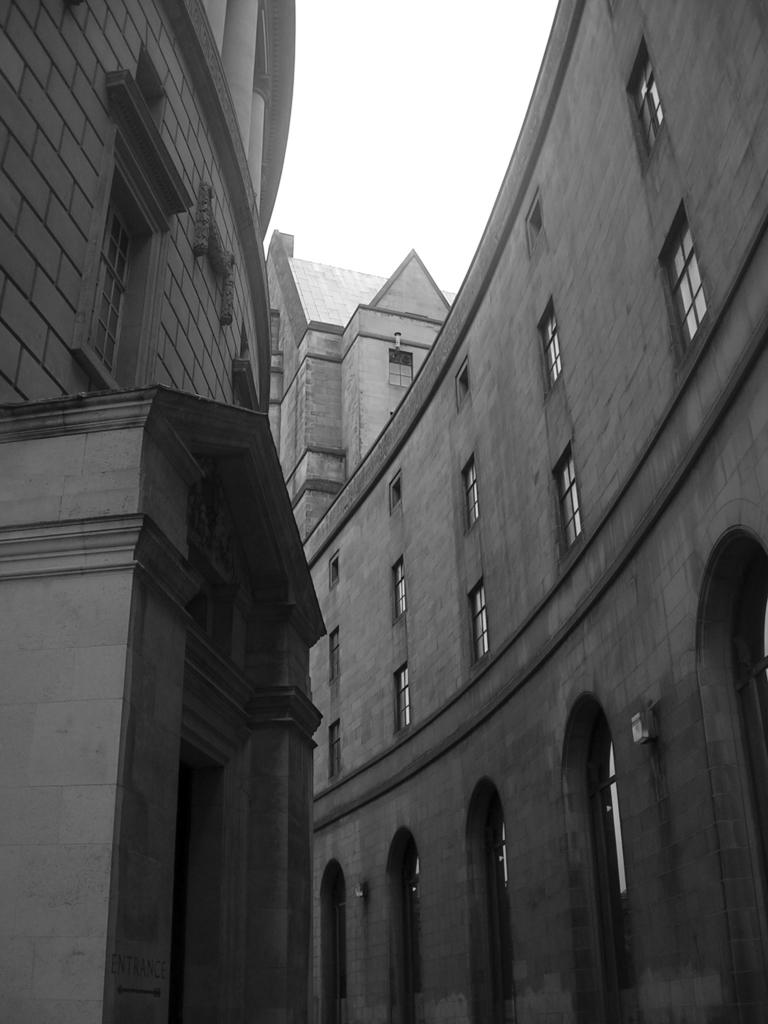What is the color scheme of the image? The image is black and white. What type of structures can be seen in the image? There are buildings in the image. What architectural feature is visible on the buildings? There are windows visible in the image. What part of the natural environment is visible in the image? The sky is visible in the image. How many items are on the list in the image? There is no list present in the image. What type of boundary can be seen in the image? There is no boundary visible in the image. 